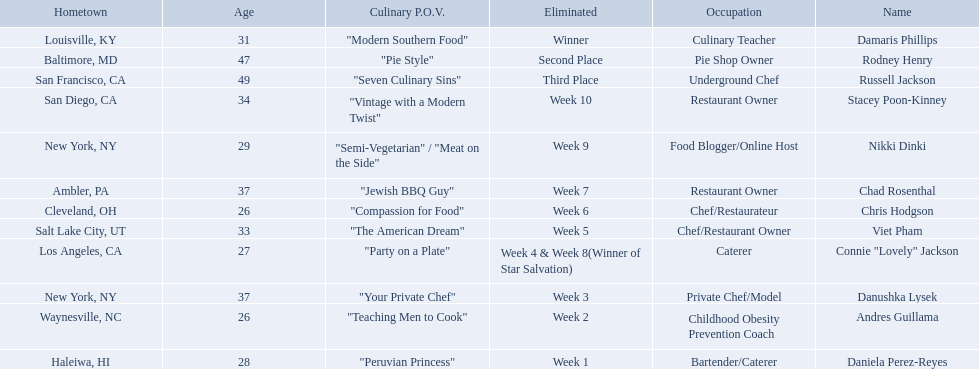Which food network star contestants are in their 20s? Nikki Dinki, Chris Hodgson, Connie "Lovely" Jackson, Andres Guillama, Daniela Perez-Reyes. Of these contestants, which one is the same age as chris hodgson? Andres Guillama. 